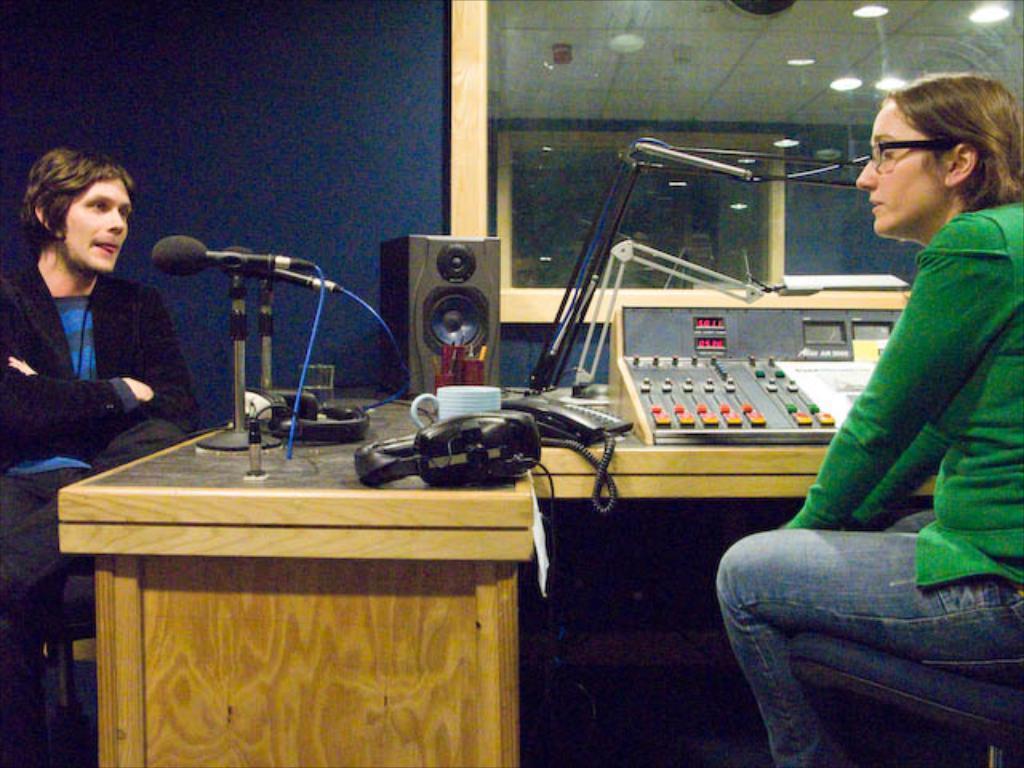Could you give a brief overview of what you see in this image? In this image I can see two persons sitting, the person at right is wearing green and blue color dress and the person at left is wearing blue and black color dress. In front I can see few microphones and few objects on the table. In the background I can see the glass, few lights and the wall is in blue color. 